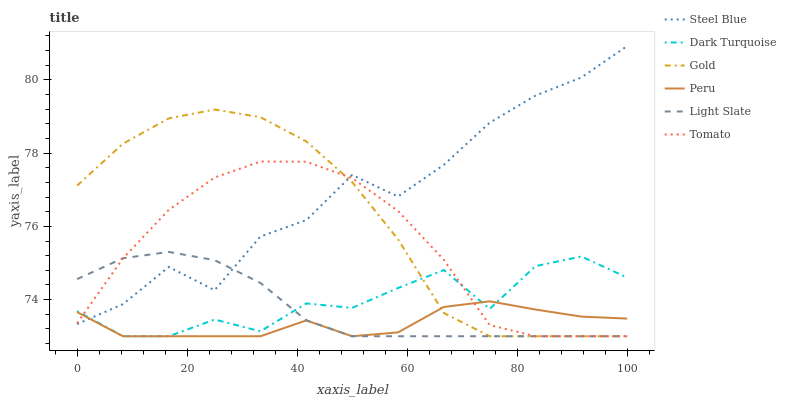Does Peru have the minimum area under the curve?
Answer yes or no. Yes. Does Steel Blue have the maximum area under the curve?
Answer yes or no. Yes. Does Gold have the minimum area under the curve?
Answer yes or no. No. Does Gold have the maximum area under the curve?
Answer yes or no. No. Is Light Slate the smoothest?
Answer yes or no. Yes. Is Steel Blue the roughest?
Answer yes or no. Yes. Is Gold the smoothest?
Answer yes or no. No. Is Gold the roughest?
Answer yes or no. No. Does Steel Blue have the lowest value?
Answer yes or no. No. Does Steel Blue have the highest value?
Answer yes or no. Yes. Does Gold have the highest value?
Answer yes or no. No. 